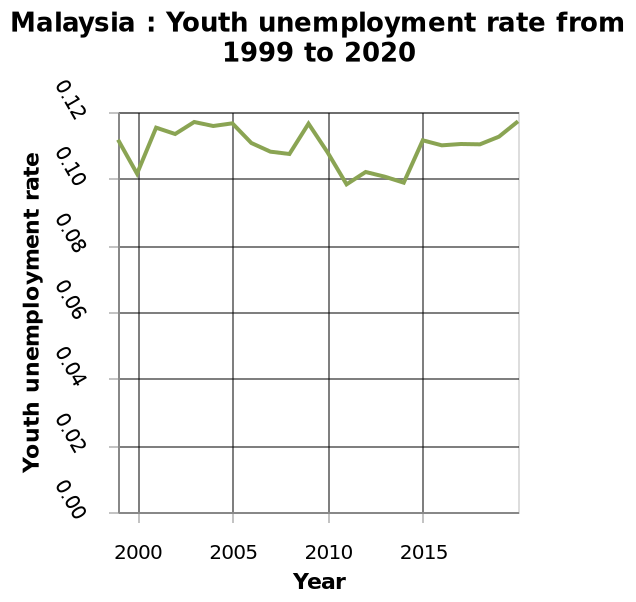<image>
During what time period was the improvement seen? The improvement was seen between 2010 to 2015. please summary the statistics and relations of the chart Between 2000 and 2015, youth unemployment rates only drop under 0.10 on two occasions. 